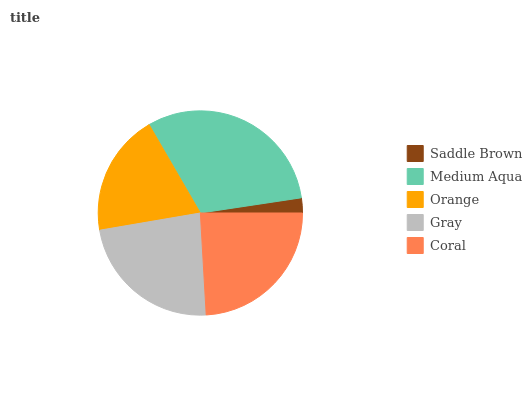Is Saddle Brown the minimum?
Answer yes or no. Yes. Is Medium Aqua the maximum?
Answer yes or no. Yes. Is Orange the minimum?
Answer yes or no. No. Is Orange the maximum?
Answer yes or no. No. Is Medium Aqua greater than Orange?
Answer yes or no. Yes. Is Orange less than Medium Aqua?
Answer yes or no. Yes. Is Orange greater than Medium Aqua?
Answer yes or no. No. Is Medium Aqua less than Orange?
Answer yes or no. No. Is Gray the high median?
Answer yes or no. Yes. Is Gray the low median?
Answer yes or no. Yes. Is Medium Aqua the high median?
Answer yes or no. No. Is Saddle Brown the low median?
Answer yes or no. No. 